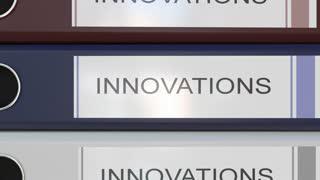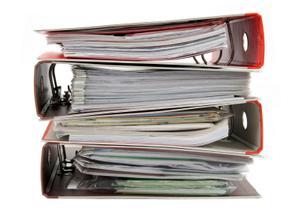The first image is the image on the left, the second image is the image on the right. Examine the images to the left and right. Is the description "An image shows the labeled ends of three stacked binders of different colors." accurate? Answer yes or no. Yes. The first image is the image on the left, the second image is the image on the right. Assess this claim about the two images: "The left image has binders with visible labels.". Correct or not? Answer yes or no. Yes. 